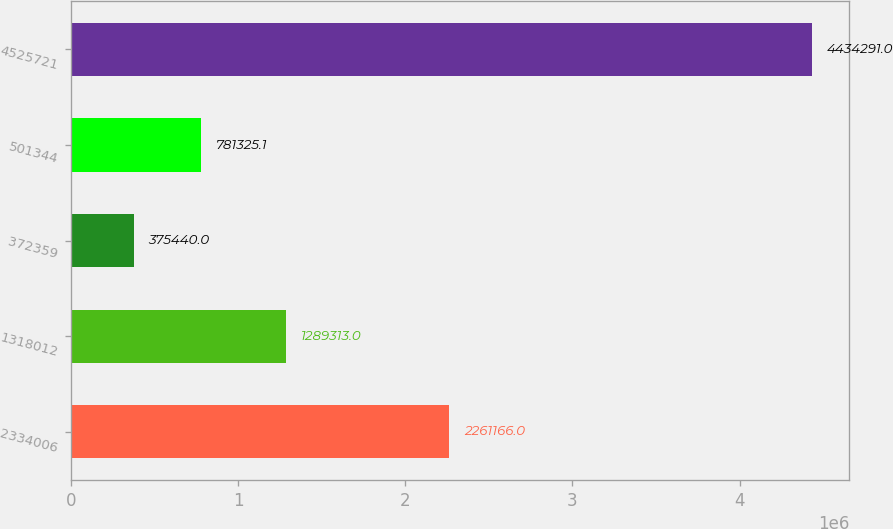<chart> <loc_0><loc_0><loc_500><loc_500><bar_chart><fcel>2334006<fcel>1318012<fcel>372359<fcel>501344<fcel>4525721<nl><fcel>2.26117e+06<fcel>1.28931e+06<fcel>375440<fcel>781325<fcel>4.43429e+06<nl></chart> 